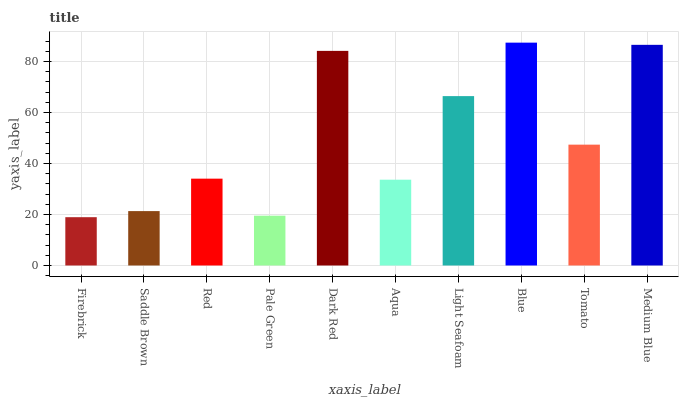Is Firebrick the minimum?
Answer yes or no. Yes. Is Blue the maximum?
Answer yes or no. Yes. Is Saddle Brown the minimum?
Answer yes or no. No. Is Saddle Brown the maximum?
Answer yes or no. No. Is Saddle Brown greater than Firebrick?
Answer yes or no. Yes. Is Firebrick less than Saddle Brown?
Answer yes or no. Yes. Is Firebrick greater than Saddle Brown?
Answer yes or no. No. Is Saddle Brown less than Firebrick?
Answer yes or no. No. Is Tomato the high median?
Answer yes or no. Yes. Is Red the low median?
Answer yes or no. Yes. Is Light Seafoam the high median?
Answer yes or no. No. Is Light Seafoam the low median?
Answer yes or no. No. 